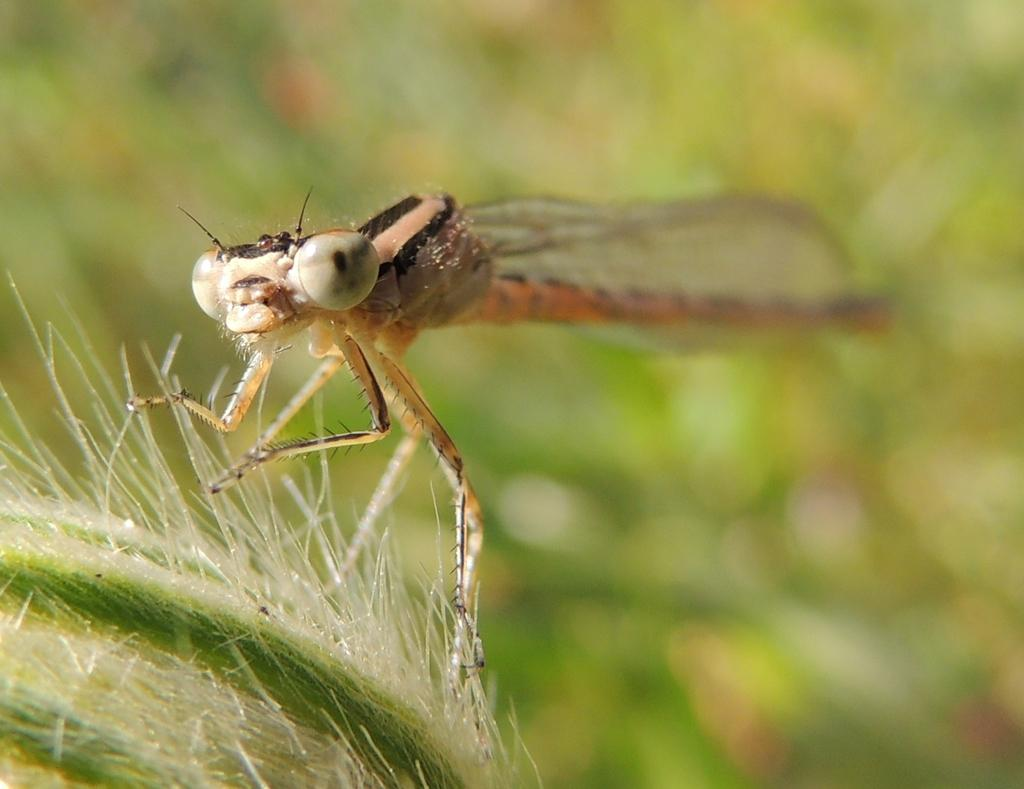What is the main subject of the image? The main subject of the image is a dragonfly. Where is the dragonfly located in the image? The dragonfly is on an object. Can you describe the background of the image? The background of the image is blurred. How many boys are playing in the channel in the image? There are no boys or channels present in the image; it features a dragonfly on an object with a blurred background. 